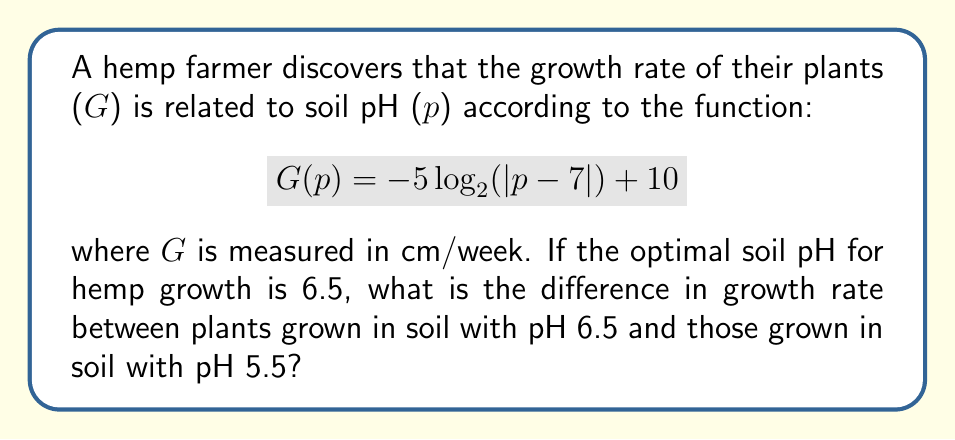Solve this math problem. To solve this problem, we need to follow these steps:

1. Calculate G(6.5) - the growth rate at optimal pH:
   $$G(6.5) = -5\log_{2}(|6.5-7|) + 10$$
   $$= -5\log_{2}(0.5) + 10$$
   $$= -5(-1) + 10 = 15 \text{ cm/week}$$

2. Calculate G(5.5) - the growth rate at pH 5.5:
   $$G(5.5) = -5\log_{2}(|5.5-7|) + 10$$
   $$= -5\log_{2}(1.5) + 10$$
   $$= -5 \cdot 0.5850 + 10 = 7.075 \text{ cm/week}$$

3. Calculate the difference in growth rate:
   Difference = G(6.5) - G(5.5)
   $$= 15 - 7.075 = 7.925 \text{ cm/week}$$

Therefore, the difference in growth rate between plants grown in soil with pH 6.5 and those grown in soil with pH 5.5 is approximately 7.925 cm/week.
Answer: 7.925 cm/week 